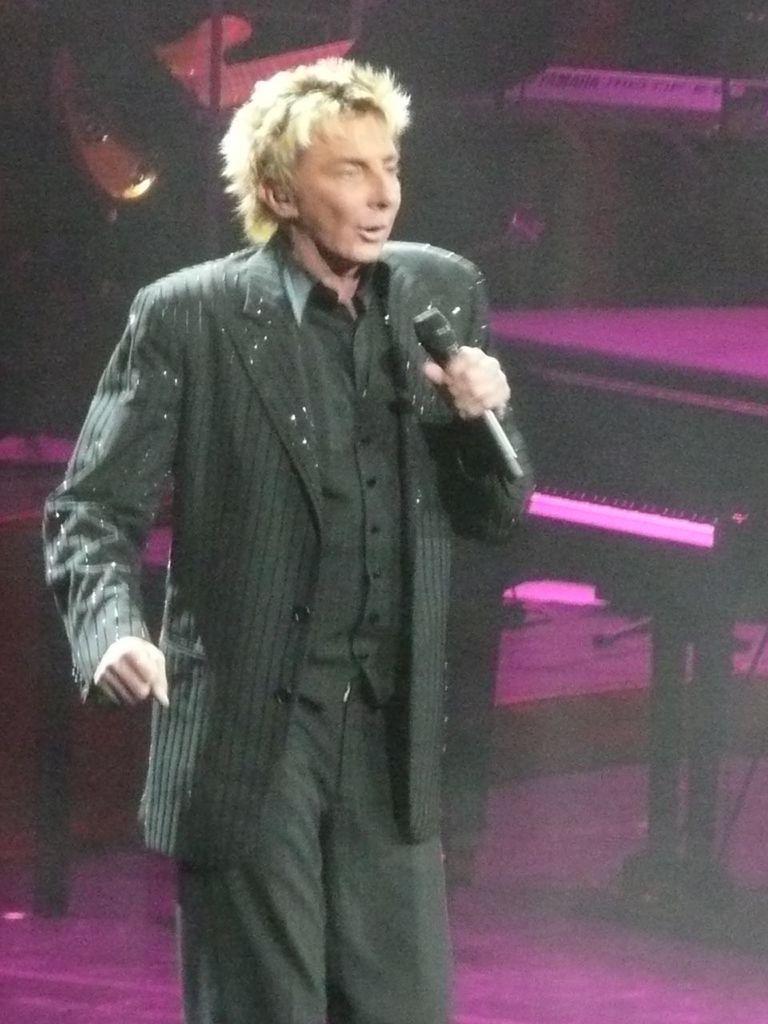In one or two sentences, can you explain what this image depicts? In this image I can see the person standing and holding the microphone and the person is wearing black color dress. In the background I can see few musical instruments. 